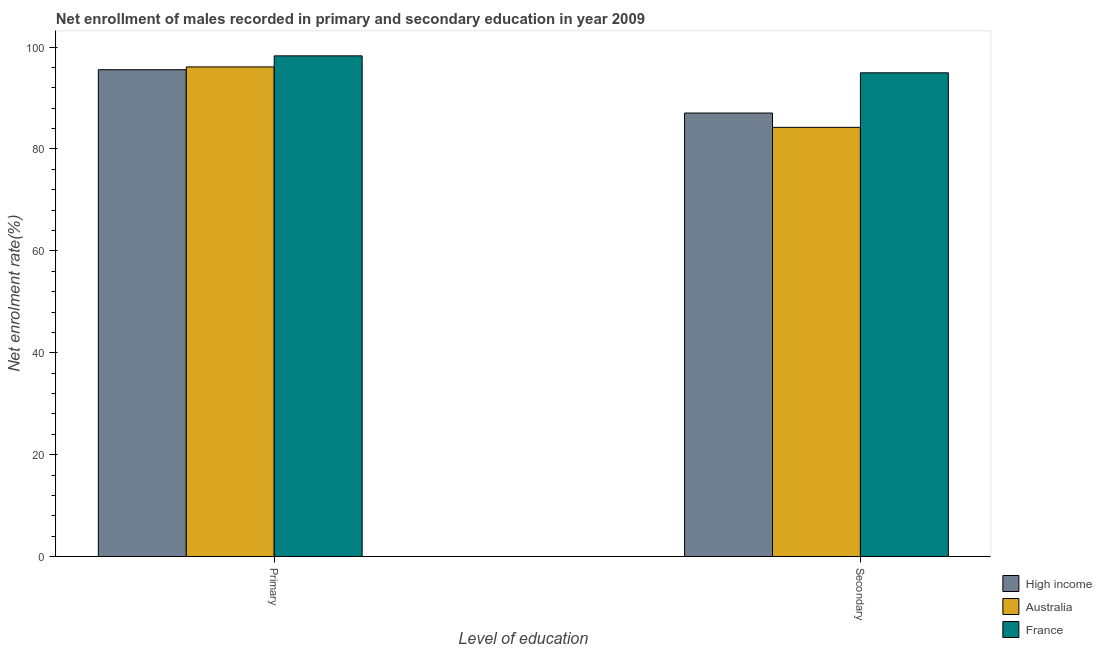Are the number of bars per tick equal to the number of legend labels?
Give a very brief answer. Yes. What is the label of the 1st group of bars from the left?
Ensure brevity in your answer.  Primary. What is the enrollment rate in secondary education in Australia?
Your response must be concise. 84.25. Across all countries, what is the maximum enrollment rate in primary education?
Provide a succinct answer. 98.28. Across all countries, what is the minimum enrollment rate in secondary education?
Your answer should be compact. 84.25. What is the total enrollment rate in primary education in the graph?
Your response must be concise. 289.96. What is the difference between the enrollment rate in secondary education in High income and that in France?
Provide a succinct answer. -7.89. What is the difference between the enrollment rate in primary education in France and the enrollment rate in secondary education in Australia?
Offer a very short reply. 14.03. What is the average enrollment rate in secondary education per country?
Offer a terse response. 88.76. What is the difference between the enrollment rate in primary education and enrollment rate in secondary education in High income?
Provide a short and direct response. 8.5. What is the ratio of the enrollment rate in primary education in High income to that in France?
Your answer should be very brief. 0.97. Is the enrollment rate in secondary education in Australia less than that in High income?
Ensure brevity in your answer.  Yes. In how many countries, is the enrollment rate in primary education greater than the average enrollment rate in primary education taken over all countries?
Keep it short and to the point. 1. What does the 3rd bar from the left in Secondary represents?
Your answer should be compact. France. What does the 1st bar from the right in Primary represents?
Offer a very short reply. France. How many bars are there?
Provide a short and direct response. 6. Are all the bars in the graph horizontal?
Make the answer very short. No. Does the graph contain any zero values?
Provide a succinct answer. No. Where does the legend appear in the graph?
Ensure brevity in your answer.  Bottom right. What is the title of the graph?
Your answer should be very brief. Net enrollment of males recorded in primary and secondary education in year 2009. What is the label or title of the X-axis?
Offer a terse response. Level of education. What is the label or title of the Y-axis?
Your answer should be compact. Net enrolment rate(%). What is the Net enrolment rate(%) in High income in Primary?
Give a very brief answer. 95.56. What is the Net enrolment rate(%) of Australia in Primary?
Make the answer very short. 96.11. What is the Net enrolment rate(%) in France in Primary?
Provide a succinct answer. 98.28. What is the Net enrolment rate(%) of High income in Secondary?
Your answer should be compact. 87.06. What is the Net enrolment rate(%) of Australia in Secondary?
Ensure brevity in your answer.  84.25. What is the Net enrolment rate(%) of France in Secondary?
Your answer should be compact. 94.96. Across all Level of education, what is the maximum Net enrolment rate(%) of High income?
Give a very brief answer. 95.56. Across all Level of education, what is the maximum Net enrolment rate(%) in Australia?
Provide a short and direct response. 96.11. Across all Level of education, what is the maximum Net enrolment rate(%) in France?
Your response must be concise. 98.28. Across all Level of education, what is the minimum Net enrolment rate(%) in High income?
Your answer should be very brief. 87.06. Across all Level of education, what is the minimum Net enrolment rate(%) of Australia?
Provide a short and direct response. 84.25. Across all Level of education, what is the minimum Net enrolment rate(%) of France?
Your answer should be very brief. 94.96. What is the total Net enrolment rate(%) of High income in the graph?
Provide a short and direct response. 182.62. What is the total Net enrolment rate(%) in Australia in the graph?
Keep it short and to the point. 180.37. What is the total Net enrolment rate(%) of France in the graph?
Your answer should be compact. 193.24. What is the difference between the Net enrolment rate(%) of High income in Primary and that in Secondary?
Offer a very short reply. 8.5. What is the difference between the Net enrolment rate(%) of Australia in Primary and that in Secondary?
Give a very brief answer. 11.86. What is the difference between the Net enrolment rate(%) of France in Primary and that in Secondary?
Provide a short and direct response. 3.33. What is the difference between the Net enrolment rate(%) in High income in Primary and the Net enrolment rate(%) in Australia in Secondary?
Make the answer very short. 11.31. What is the difference between the Net enrolment rate(%) in High income in Primary and the Net enrolment rate(%) in France in Secondary?
Provide a short and direct response. 0.61. What is the difference between the Net enrolment rate(%) in Australia in Primary and the Net enrolment rate(%) in France in Secondary?
Ensure brevity in your answer.  1.16. What is the average Net enrolment rate(%) in High income per Level of education?
Your answer should be compact. 91.31. What is the average Net enrolment rate(%) in Australia per Level of education?
Keep it short and to the point. 90.18. What is the average Net enrolment rate(%) in France per Level of education?
Your response must be concise. 96.62. What is the difference between the Net enrolment rate(%) of High income and Net enrolment rate(%) of Australia in Primary?
Make the answer very short. -0.55. What is the difference between the Net enrolment rate(%) in High income and Net enrolment rate(%) in France in Primary?
Keep it short and to the point. -2.72. What is the difference between the Net enrolment rate(%) of Australia and Net enrolment rate(%) of France in Primary?
Your response must be concise. -2.17. What is the difference between the Net enrolment rate(%) in High income and Net enrolment rate(%) in Australia in Secondary?
Offer a very short reply. 2.81. What is the difference between the Net enrolment rate(%) in High income and Net enrolment rate(%) in France in Secondary?
Ensure brevity in your answer.  -7.89. What is the difference between the Net enrolment rate(%) in Australia and Net enrolment rate(%) in France in Secondary?
Provide a succinct answer. -10.7. What is the ratio of the Net enrolment rate(%) in High income in Primary to that in Secondary?
Offer a terse response. 1.1. What is the ratio of the Net enrolment rate(%) of Australia in Primary to that in Secondary?
Your response must be concise. 1.14. What is the ratio of the Net enrolment rate(%) in France in Primary to that in Secondary?
Make the answer very short. 1.04. What is the difference between the highest and the second highest Net enrolment rate(%) in High income?
Give a very brief answer. 8.5. What is the difference between the highest and the second highest Net enrolment rate(%) in Australia?
Give a very brief answer. 11.86. What is the difference between the highest and the second highest Net enrolment rate(%) in France?
Ensure brevity in your answer.  3.33. What is the difference between the highest and the lowest Net enrolment rate(%) of High income?
Your response must be concise. 8.5. What is the difference between the highest and the lowest Net enrolment rate(%) in Australia?
Your answer should be compact. 11.86. What is the difference between the highest and the lowest Net enrolment rate(%) of France?
Your answer should be compact. 3.33. 